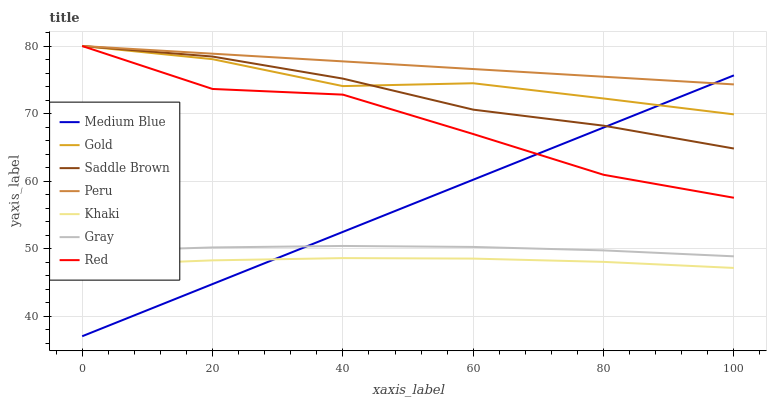Does Gold have the minimum area under the curve?
Answer yes or no. No. Does Gold have the maximum area under the curve?
Answer yes or no. No. Is Khaki the smoothest?
Answer yes or no. No. Is Khaki the roughest?
Answer yes or no. No. Does Khaki have the lowest value?
Answer yes or no. No. Does Khaki have the highest value?
Answer yes or no. No. Is Khaki less than Gold?
Answer yes or no. Yes. Is Red greater than Khaki?
Answer yes or no. Yes. Does Khaki intersect Gold?
Answer yes or no. No. 